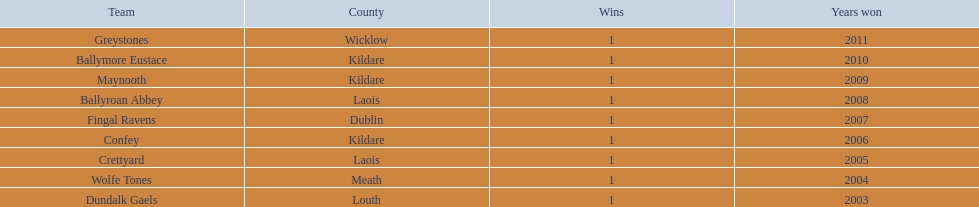Where is ballymore eustace from? Kildare. What teams other than ballymore eustace is from kildare? Maynooth, Confey. Between maynooth and confey, which won in 2009? Maynooth. 